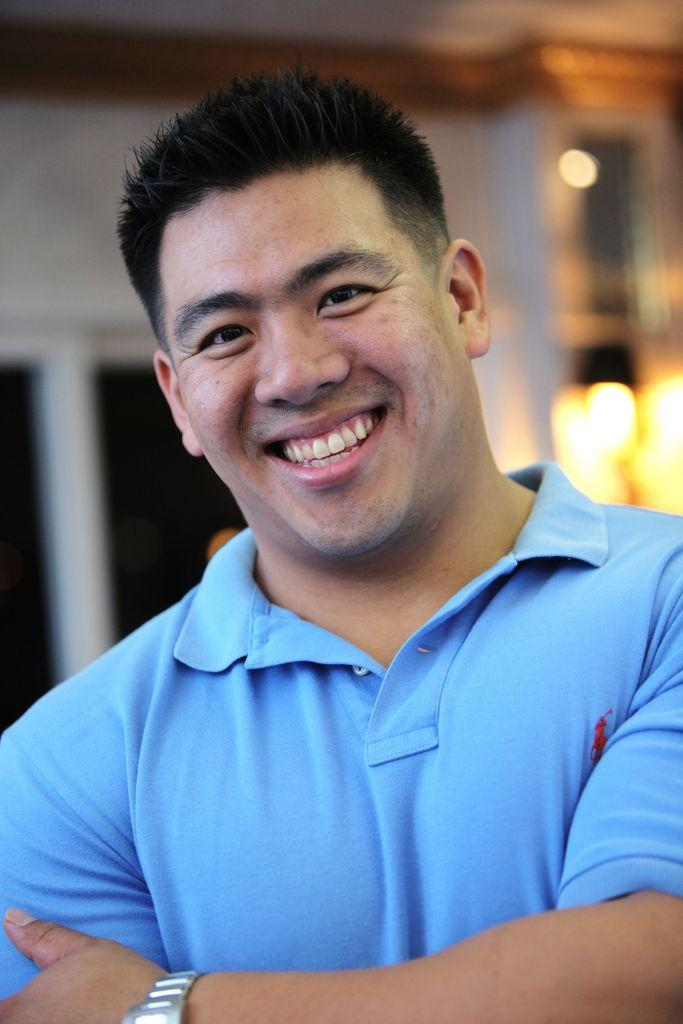What is the main subject of the image? There is a man in the image. What is the man's facial expression? The man is smiling. What color is the t-shirt the man is wearing? The man is wearing a blue t-shirt. What type of fish can be seen swimming in the background of the image? There are no fish present in the image; it features a man wearing a blue t-shirt and smiling. 